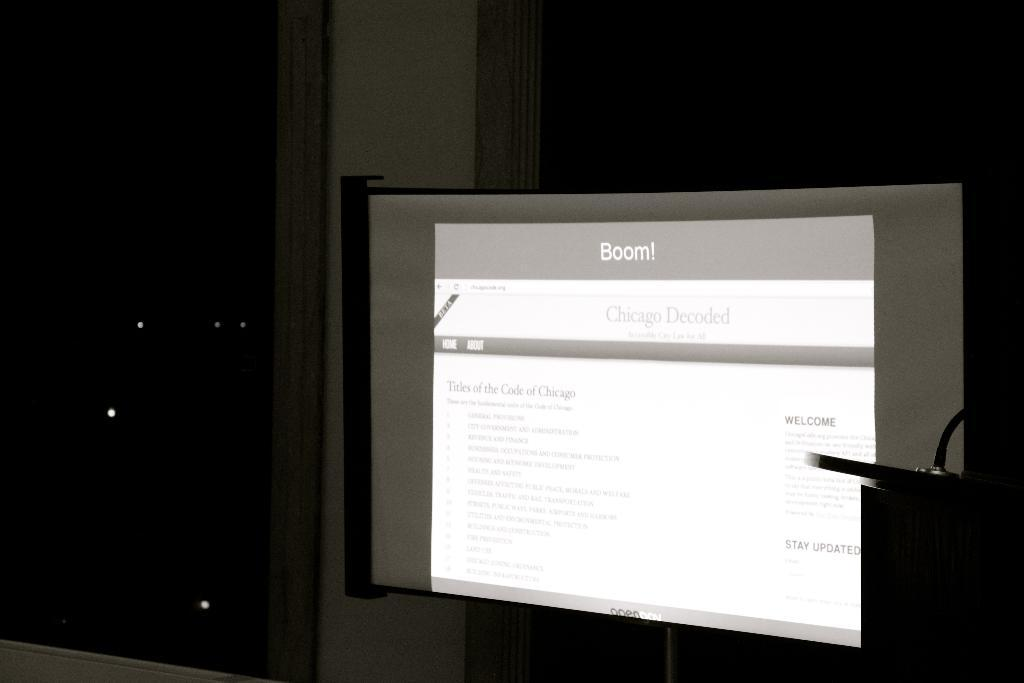<image>
Provide a brief description of the given image. Computer monitor screen that shows the word Boom on top. 